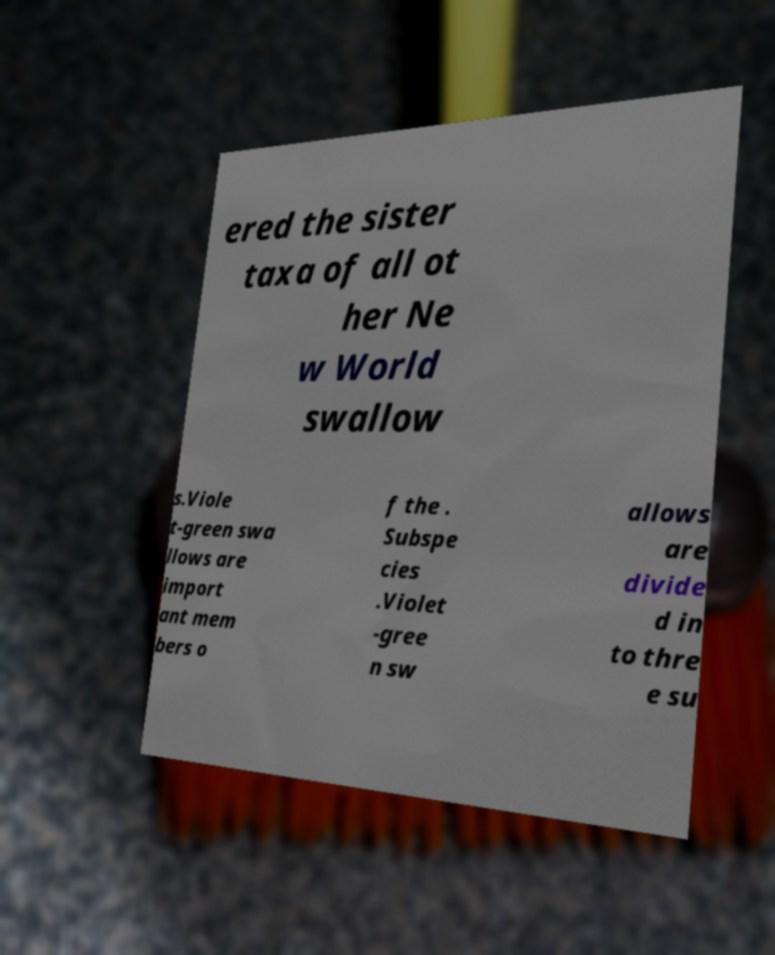There's text embedded in this image that I need extracted. Can you transcribe it verbatim? ered the sister taxa of all ot her Ne w World swallow s.Viole t-green swa llows are import ant mem bers o f the . Subspe cies .Violet -gree n sw allows are divide d in to thre e su 